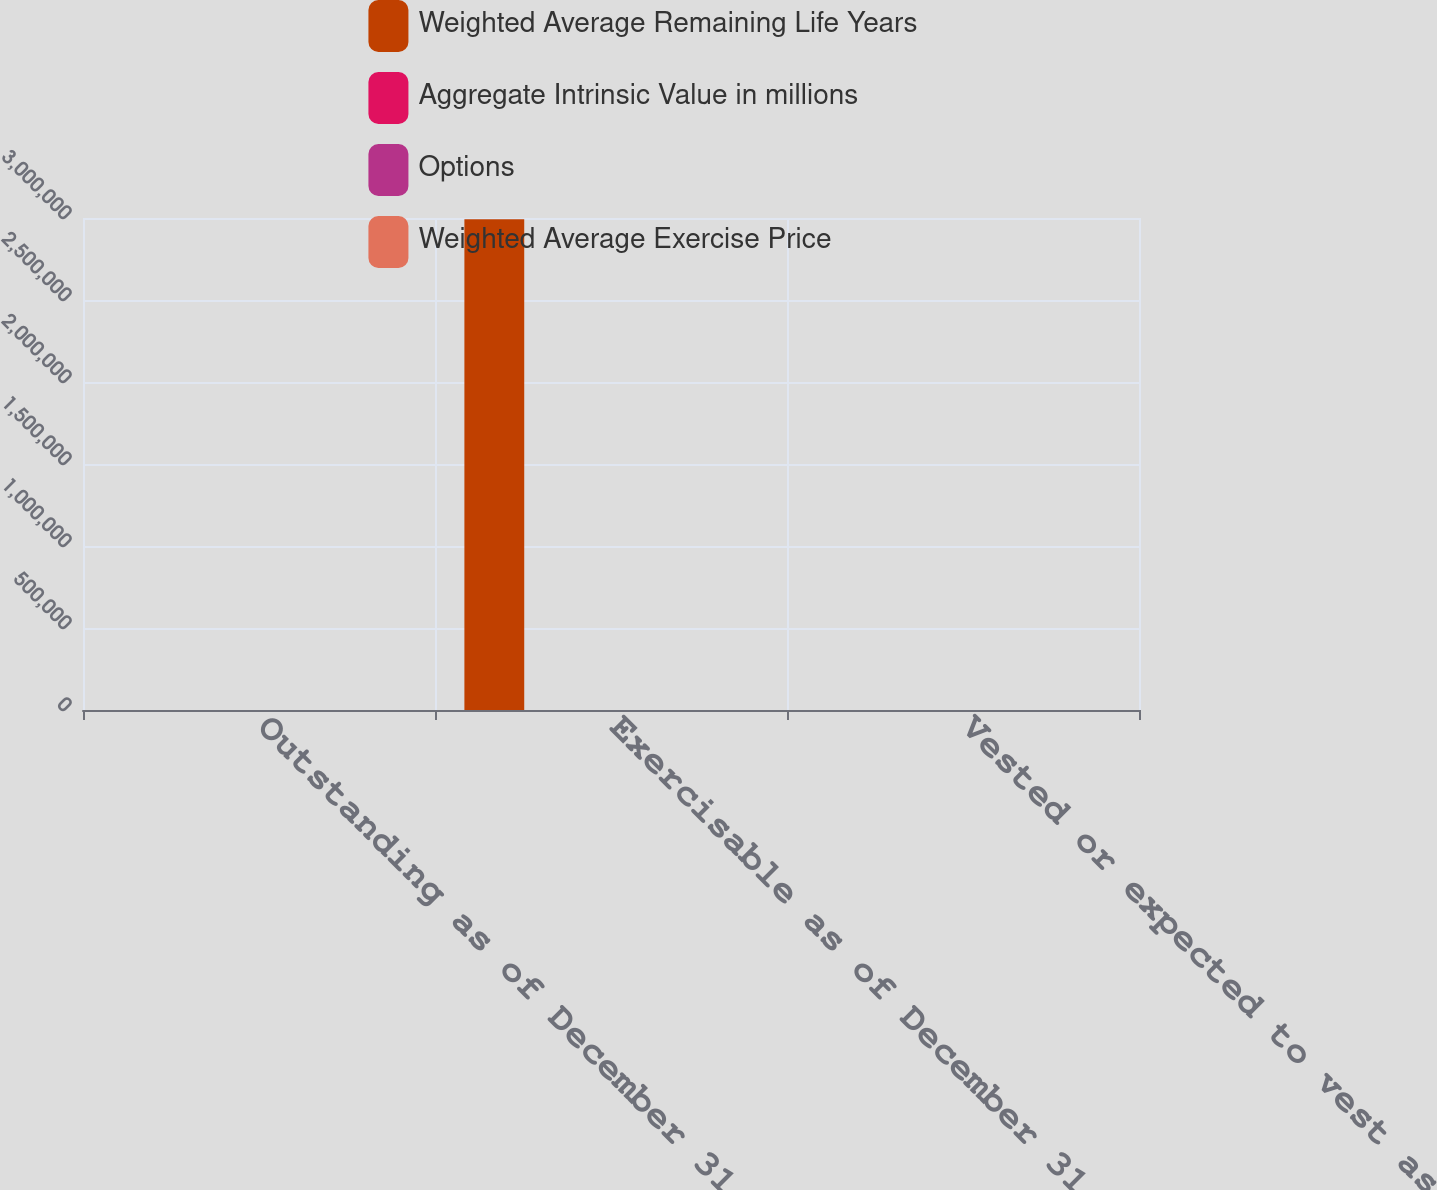<chart> <loc_0><loc_0><loc_500><loc_500><stacked_bar_chart><ecel><fcel>Outstanding as of December 31<fcel>Exercisable as of December 31<fcel>Vested or expected to vest as<nl><fcel>Weighted Average Remaining Life Years<fcel>62.135<fcel>2.99225e+06<fcel>62.135<nl><fcel>Aggregate Intrinsic Value in millions<fcel>62.14<fcel>46.77<fcel>62.13<nl><fcel>Options<fcel>6.77<fcel>4.84<fcel>6.77<nl><fcel>Weighted Average Exercise Price<fcel>238.9<fcel>155.8<fcel>238.9<nl></chart> 